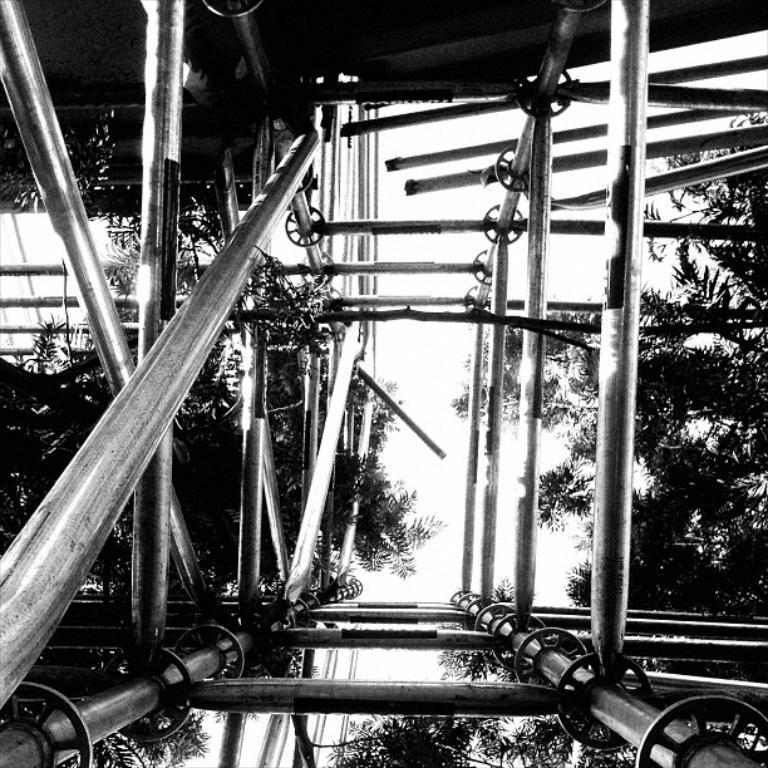Could you give a brief overview of what you see in this image? This is a black and white picture, in this image we can see some metal rods, there are some trees and also at the top we can see the roof. 